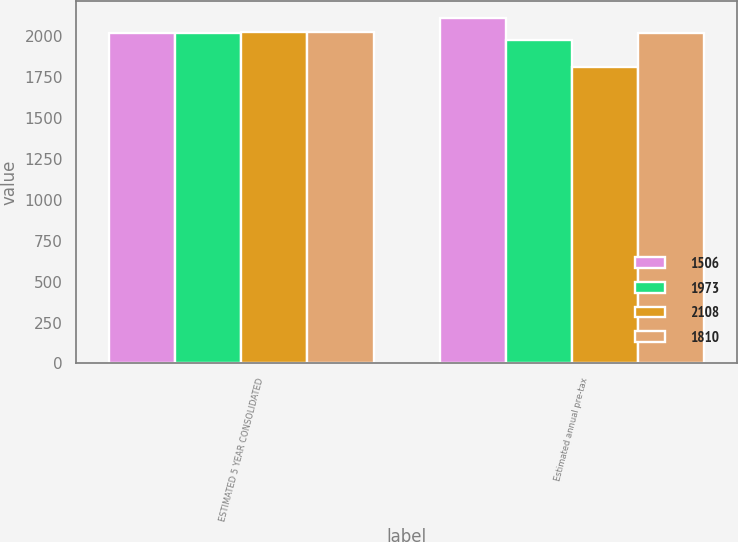Convert chart to OTSL. <chart><loc_0><loc_0><loc_500><loc_500><stacked_bar_chart><ecel><fcel>ESTIMATED 5 YEAR CONSOLIDATED<fcel>Estimated annual pre-tax<nl><fcel>1506<fcel>2019<fcel>2108<nl><fcel>1973<fcel>2020<fcel>1973<nl><fcel>2108<fcel>2021<fcel>1810<nl><fcel>1810<fcel>2022<fcel>2020<nl></chart> 